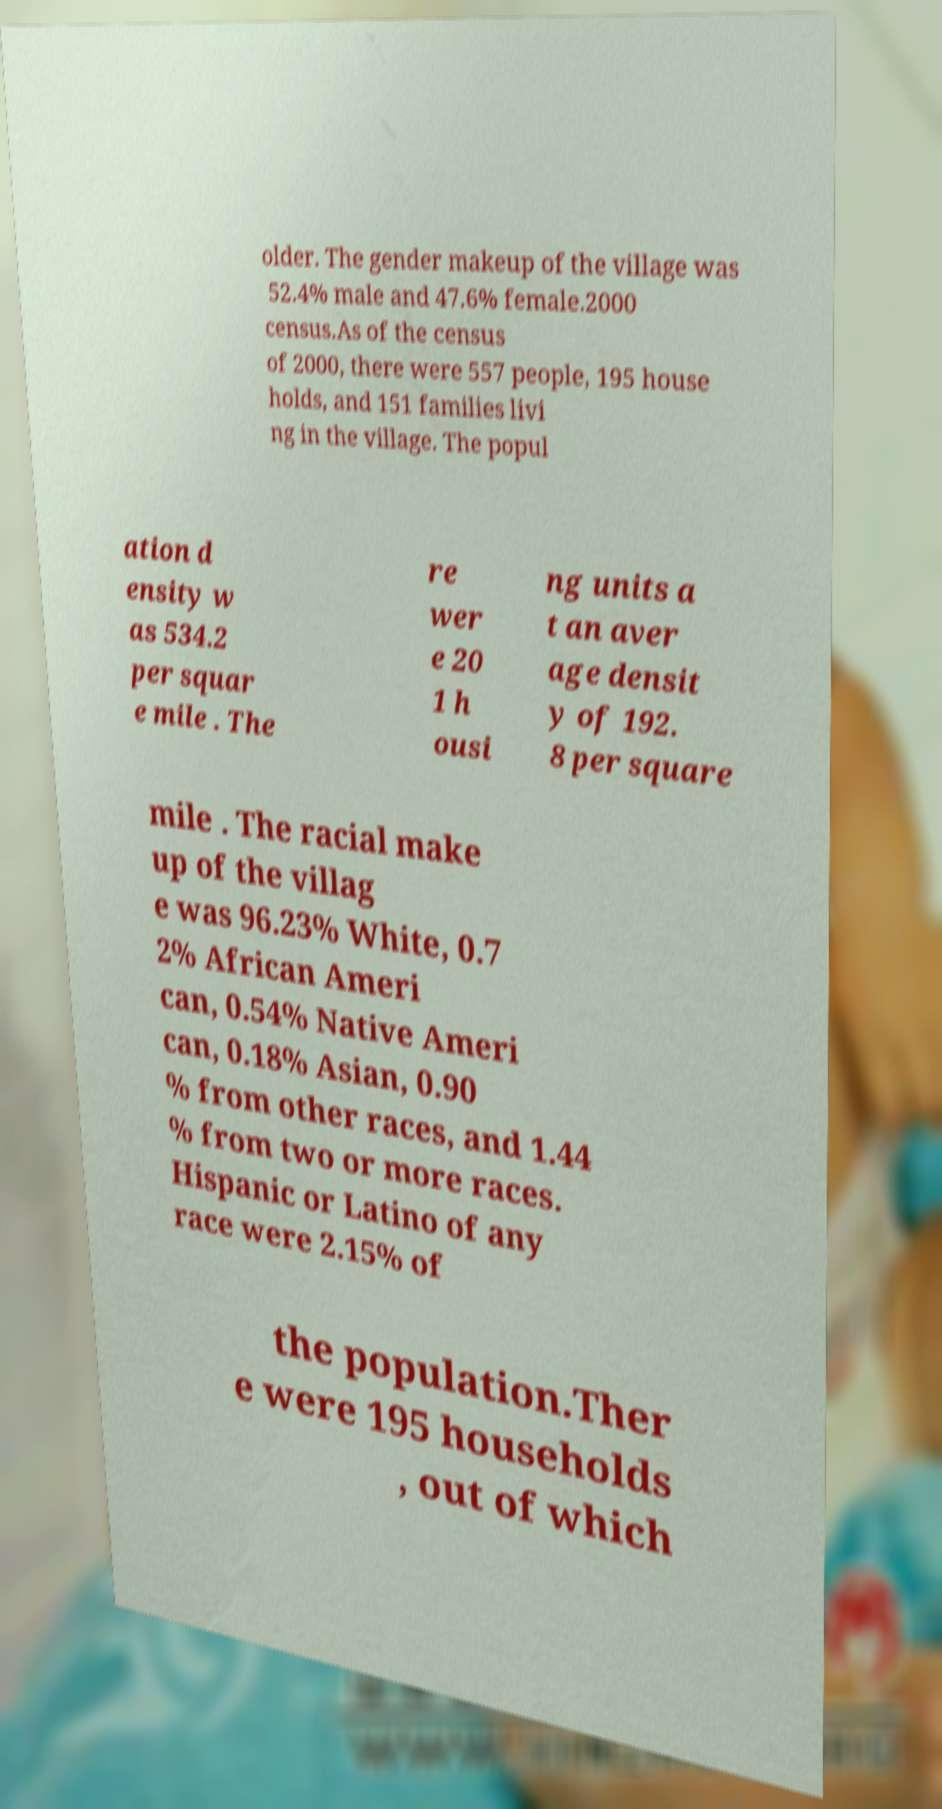Please read and relay the text visible in this image. What does it say? older. The gender makeup of the village was 52.4% male and 47.6% female.2000 census.As of the census of 2000, there were 557 people, 195 house holds, and 151 families livi ng in the village. The popul ation d ensity w as 534.2 per squar e mile . The re wer e 20 1 h ousi ng units a t an aver age densit y of 192. 8 per square mile . The racial make up of the villag e was 96.23% White, 0.7 2% African Ameri can, 0.54% Native Ameri can, 0.18% Asian, 0.90 % from other races, and 1.44 % from two or more races. Hispanic or Latino of any race were 2.15% of the population.Ther e were 195 households , out of which 